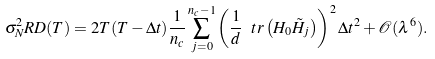<formula> <loc_0><loc_0><loc_500><loc_500>\sigma ^ { 2 } _ { N } R D ( T ) = 2 T ( T - \Delta t ) \frac { 1 } { n _ { c } } \sum _ { j = 0 } ^ { n _ { c } - 1 } \left ( \frac { 1 } { d } \ t r \left ( H _ { 0 } \tilde { H } _ { j } \right ) \right ) ^ { 2 } \Delta t ^ { 2 } + \mathcal { O } ( \lambda ^ { 6 } ) .</formula> 